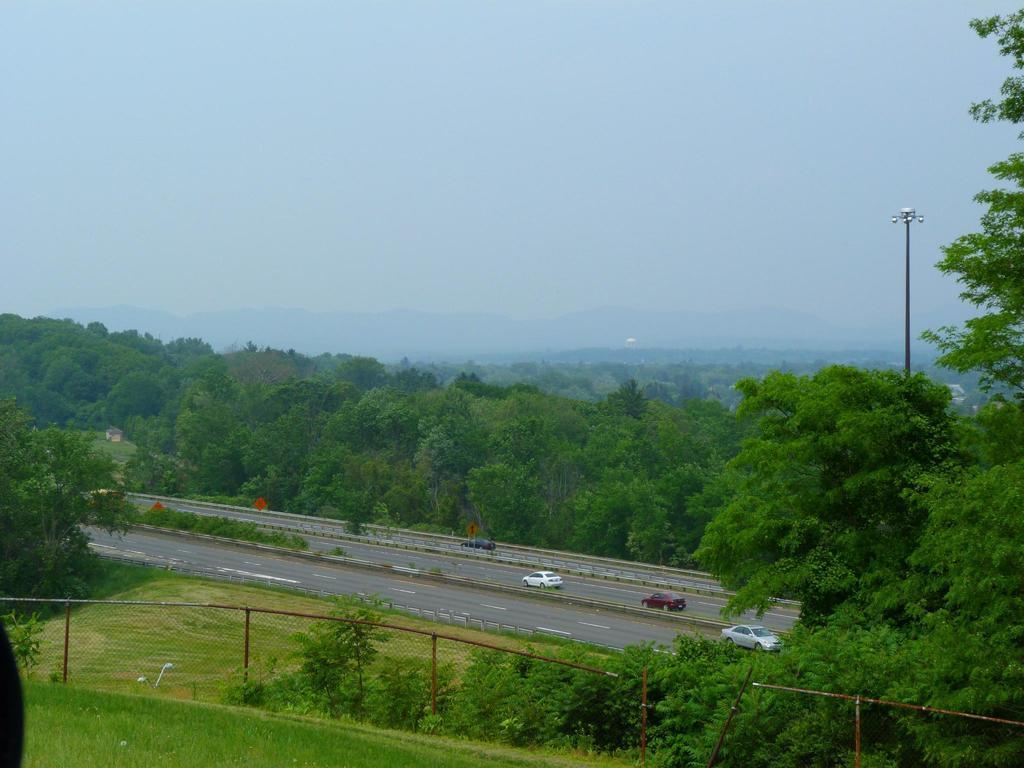Can you describe this image briefly? In this picture I can observe a road on which some cars are moving. There is a railing on the bottom of the picture. I can observe some plants on the ground. In the background there are trees and a sky. 